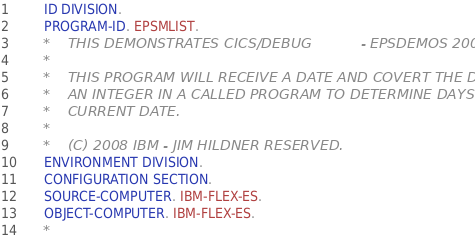Convert code to text. <code><loc_0><loc_0><loc_500><loc_500><_COBOL_>       ID DIVISION.
       PROGRAM-ID. EPSMLIST.
      *    THIS DEMONSTRATES CICS/DEBUG           - EPSDEMOS 2008
      *
      *    THIS PROGRAM WILL RECEIVE A DATE AND COVERT THE DATE TO
      *    AN INTEGER IN A CALLED PROGRAM TO DETERMINE DAYS FROM
      *    CURRENT DATE.
      *
      *    (C) 2008 IBM - JIM HILDNER RESERVED.
       ENVIRONMENT DIVISION.
       CONFIGURATION SECTION.
       SOURCE-COMPUTER. IBM-FLEX-ES.
       OBJECT-COMPUTER. IBM-FLEX-ES.
      *</code> 